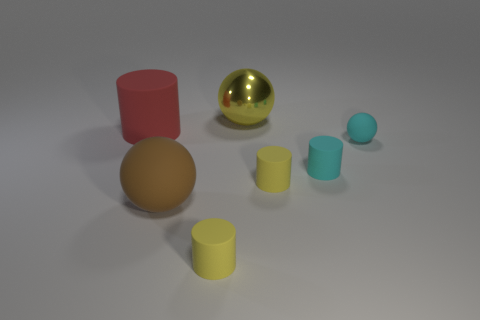Add 2 big red things. How many objects exist? 9 Subtract all cylinders. How many objects are left? 3 Subtract 0 blue spheres. How many objects are left? 7 Subtract all large brown objects. Subtract all large red metallic blocks. How many objects are left? 6 Add 5 small matte cylinders. How many small matte cylinders are left? 8 Add 3 large yellow spheres. How many large yellow spheres exist? 4 